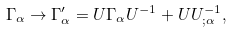Convert formula to latex. <formula><loc_0><loc_0><loc_500><loc_500>\Gamma _ { \alpha } \to { \Gamma } ^ { \prime } _ { \alpha } = U \Gamma _ { \alpha } U ^ { - 1 } + U U ^ { - 1 } _ { ; \alpha } ,</formula> 